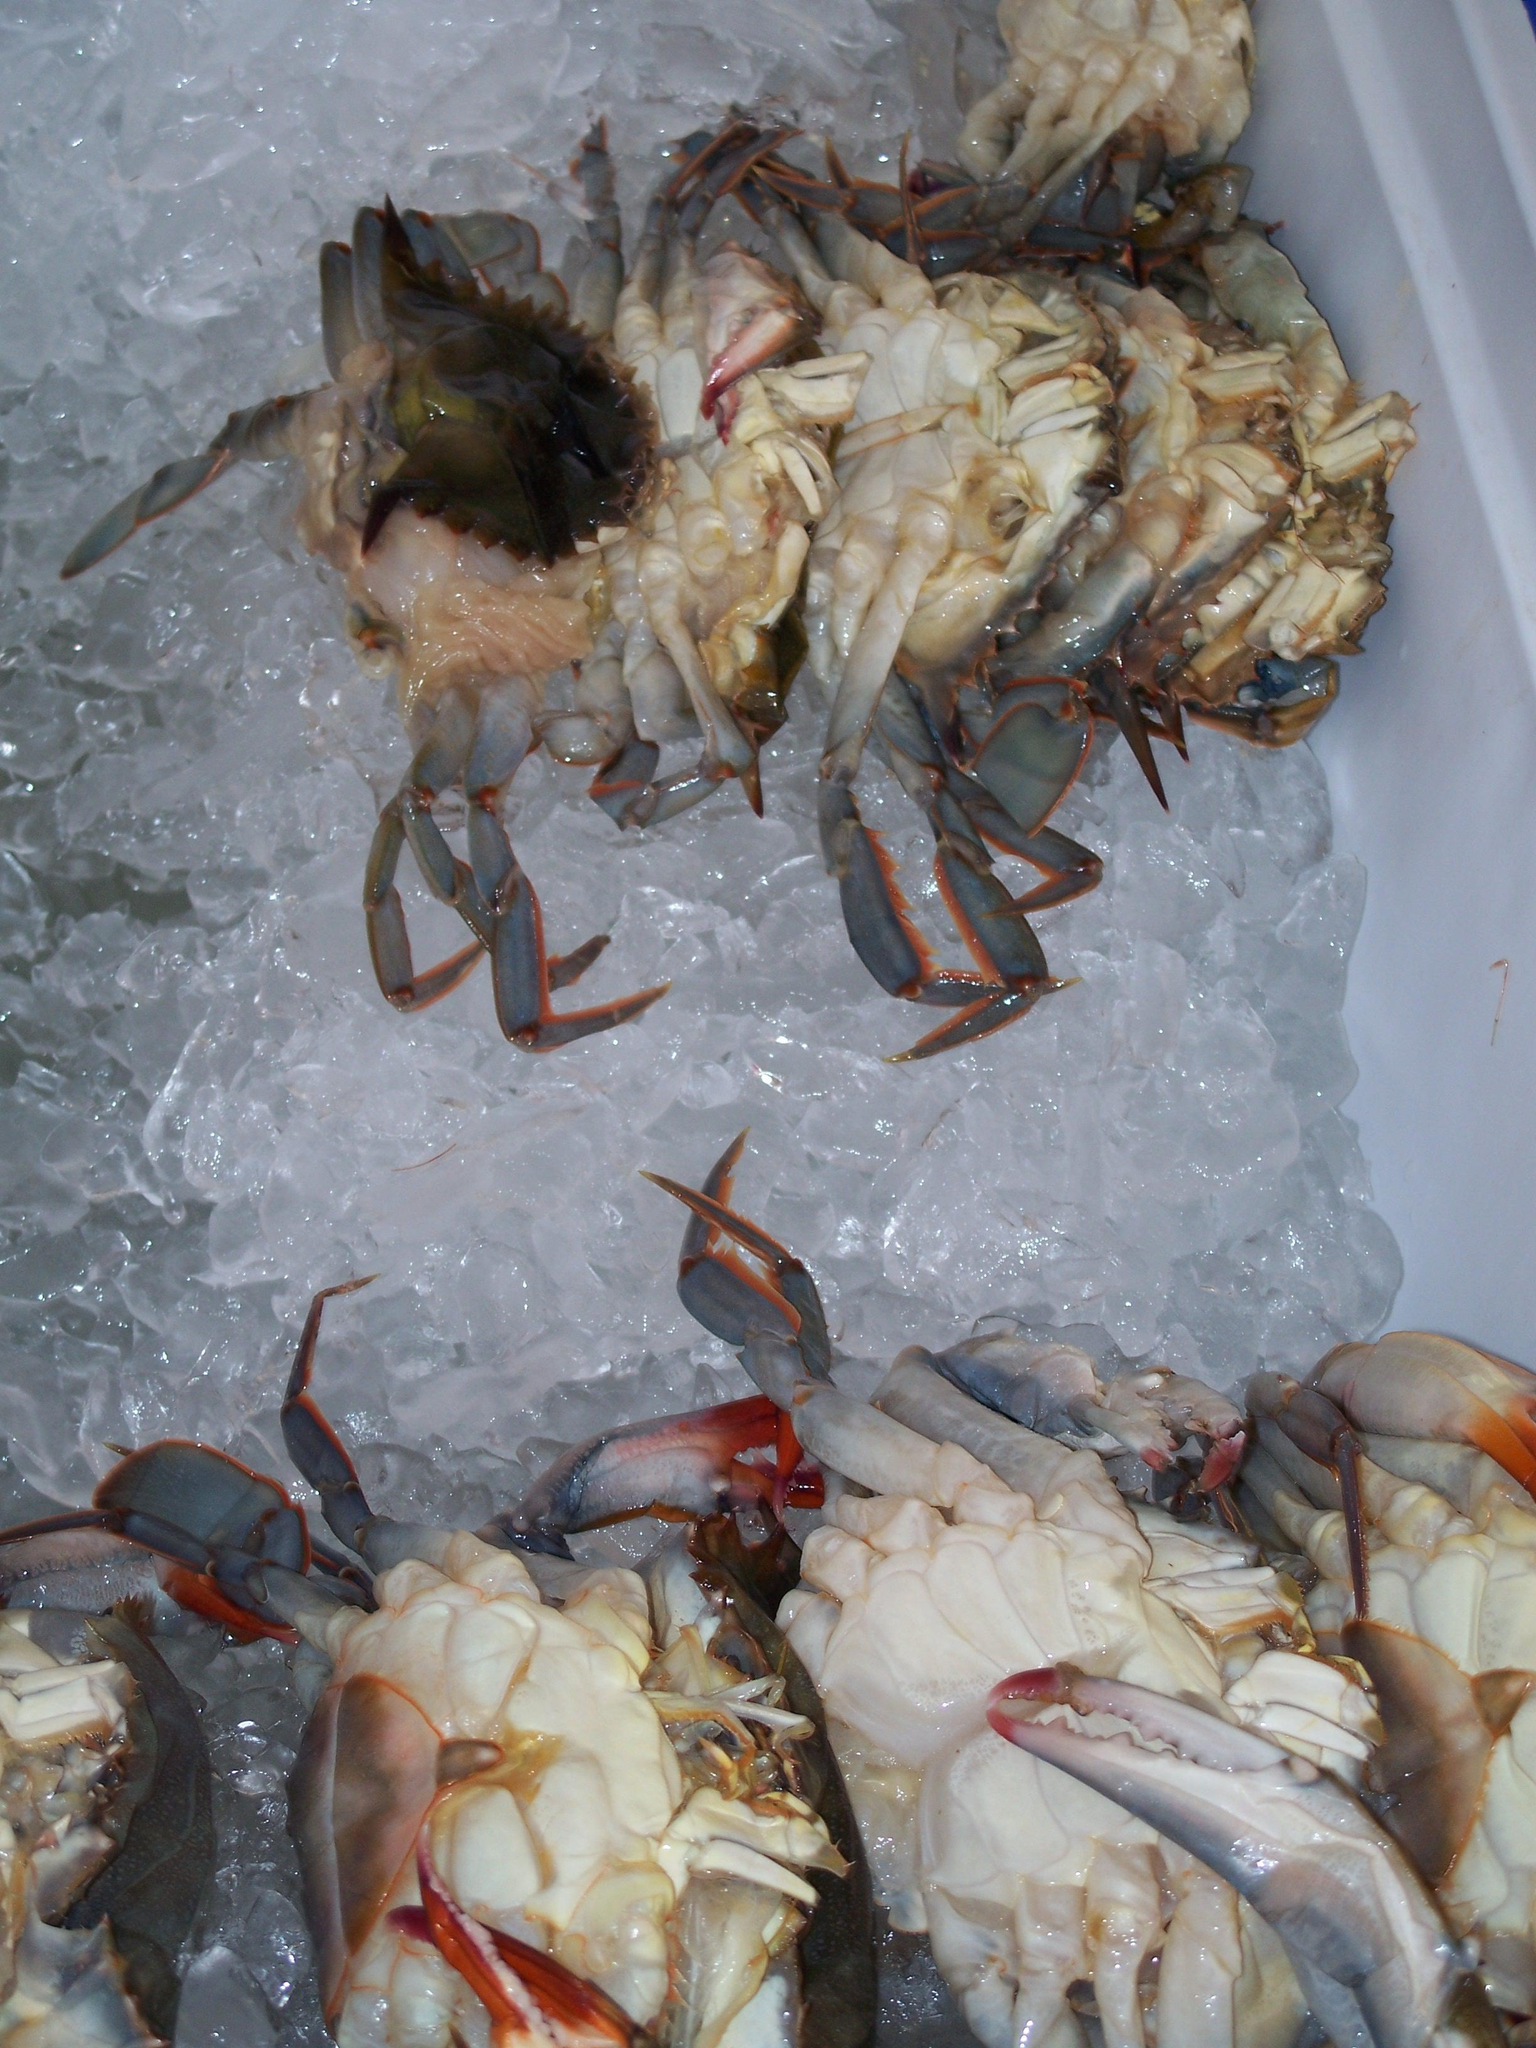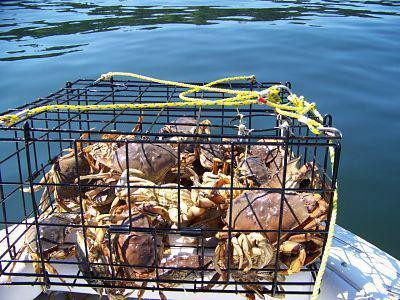The first image is the image on the left, the second image is the image on the right. For the images shown, is this caption "At least one image shows crabs in a container with a grid of squares and a metal frame." true? Answer yes or no. Yes. The first image is the image on the left, the second image is the image on the right. Assess this claim about the two images: "There are crabs in cages.". Correct or not? Answer yes or no. Yes. 